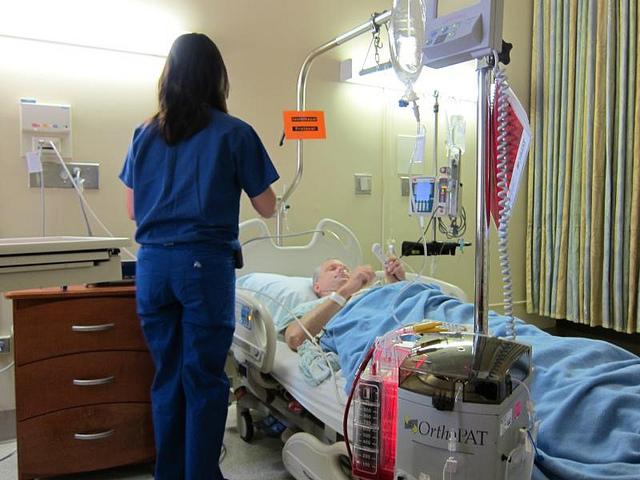Is the man asleep?
Short answer required. No. Where is this?
Quick response, please. Hospital. Is there nurse wearing scrubs?
Concise answer only. Yes. 